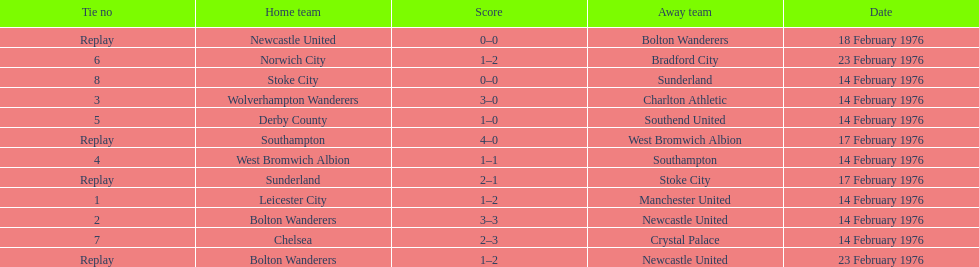Would you be able to parse every entry in this table? {'header': ['Tie no', 'Home team', 'Score', 'Away team', 'Date'], 'rows': [['Replay', 'Newcastle United', '0–0', 'Bolton Wanderers', '18 February 1976'], ['6', 'Norwich City', '1–2', 'Bradford City', '23 February 1976'], ['8', 'Stoke City', '0–0', 'Sunderland', '14 February 1976'], ['3', 'Wolverhampton Wanderers', '3–0', 'Charlton Athletic', '14 February 1976'], ['5', 'Derby County', '1–0', 'Southend United', '14 February 1976'], ['Replay', 'Southampton', '4–0', 'West Bromwich Albion', '17 February 1976'], ['4', 'West Bromwich Albion', '1–1', 'Southampton', '14 February 1976'], ['Replay', 'Sunderland', '2–1', 'Stoke City', '17 February 1976'], ['1', 'Leicester City', '1–2', 'Manchester United', '14 February 1976'], ['2', 'Bolton Wanderers', '3–3', 'Newcastle United', '14 February 1976'], ['7', 'Chelsea', '2–3', 'Crystal Palace', '14 February 1976'], ['Replay', 'Bolton Wanderers', '1–2', 'Newcastle United', '23 February 1976']]} How many games did the bolton wanderers and newcastle united play before there was a definitive winner in the fifth round proper? 3. 